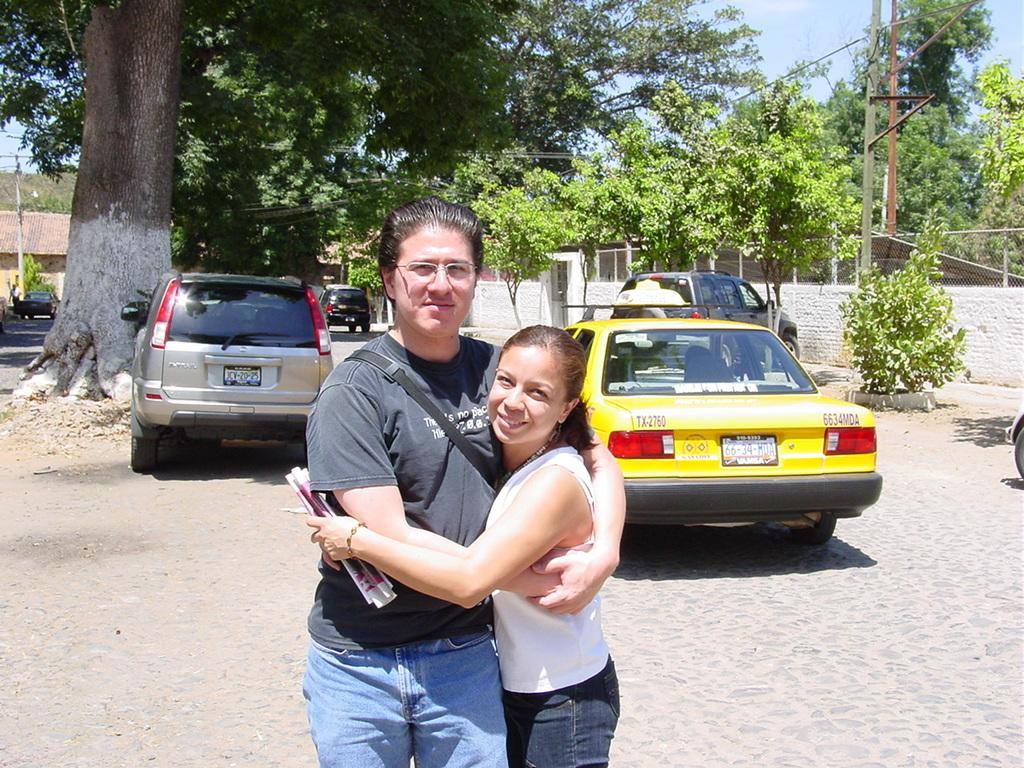Provide a one-sentence caption for the provided image. Two people hug each other behind taxi number TX-2760. 